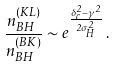Convert formula to latex. <formula><loc_0><loc_0><loc_500><loc_500>\frac { n _ { B H } ^ { ( K L ) } } { n _ { B H } ^ { ( B K ) } } \sim e ^ { \frac { \delta _ { c } ^ { 2 } - \gamma ^ { 2 } } { 2 \sigma _ { H } ^ { 2 } } } \, .</formula> 